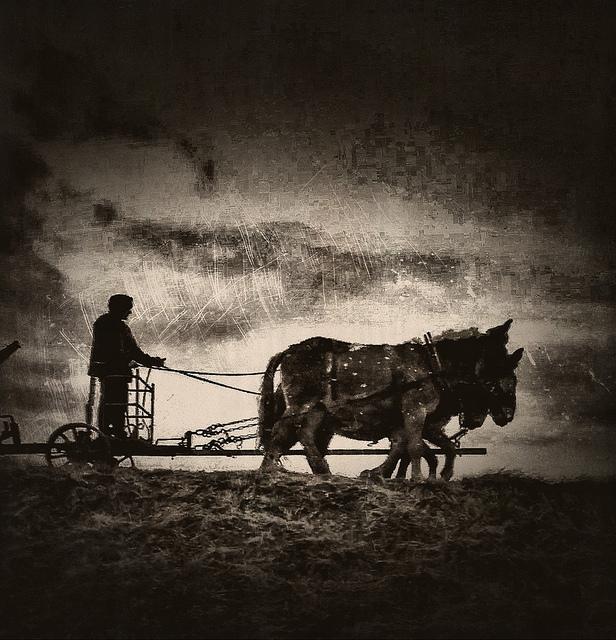Are the horses friendly?
Quick response, please. Yes. How many horses?
Concise answer only. 2. How many people are in this scene?
Concise answer only. 1. 